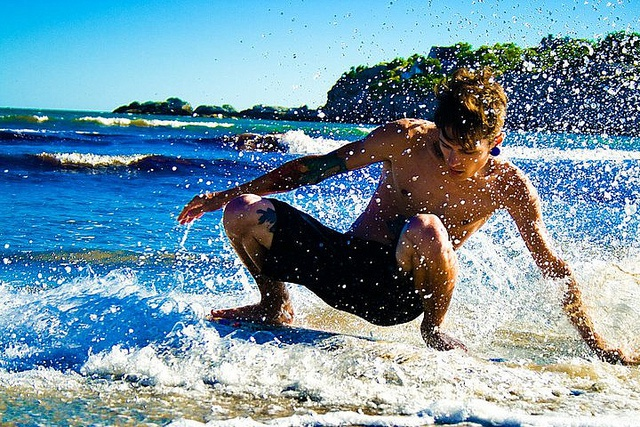Describe the objects in this image and their specific colors. I can see people in lightblue, black, maroon, and white tones and surfboard in lightblue, blue, white, and navy tones in this image. 